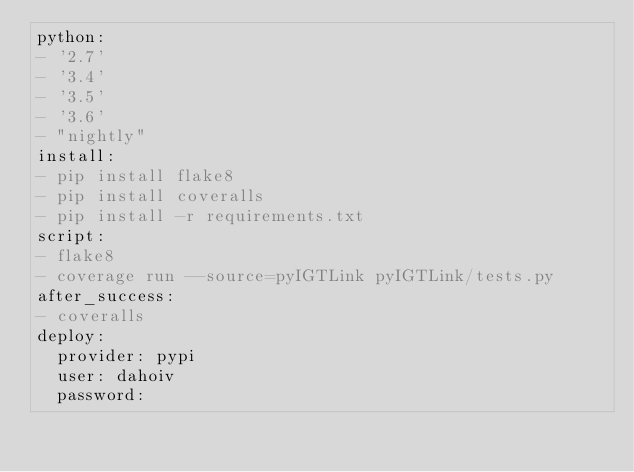<code> <loc_0><loc_0><loc_500><loc_500><_YAML_>python:
- '2.7'
- '3.4'
- '3.5'
- '3.6'
- "nightly"
install:
- pip install flake8
- pip install coveralls
- pip install -r requirements.txt
script:
- flake8
- coverage run --source=pyIGTLink pyIGTLink/tests.py
after_success:
- coveralls
deploy:
  provider: pypi
  user: dahoiv
  password:</code> 